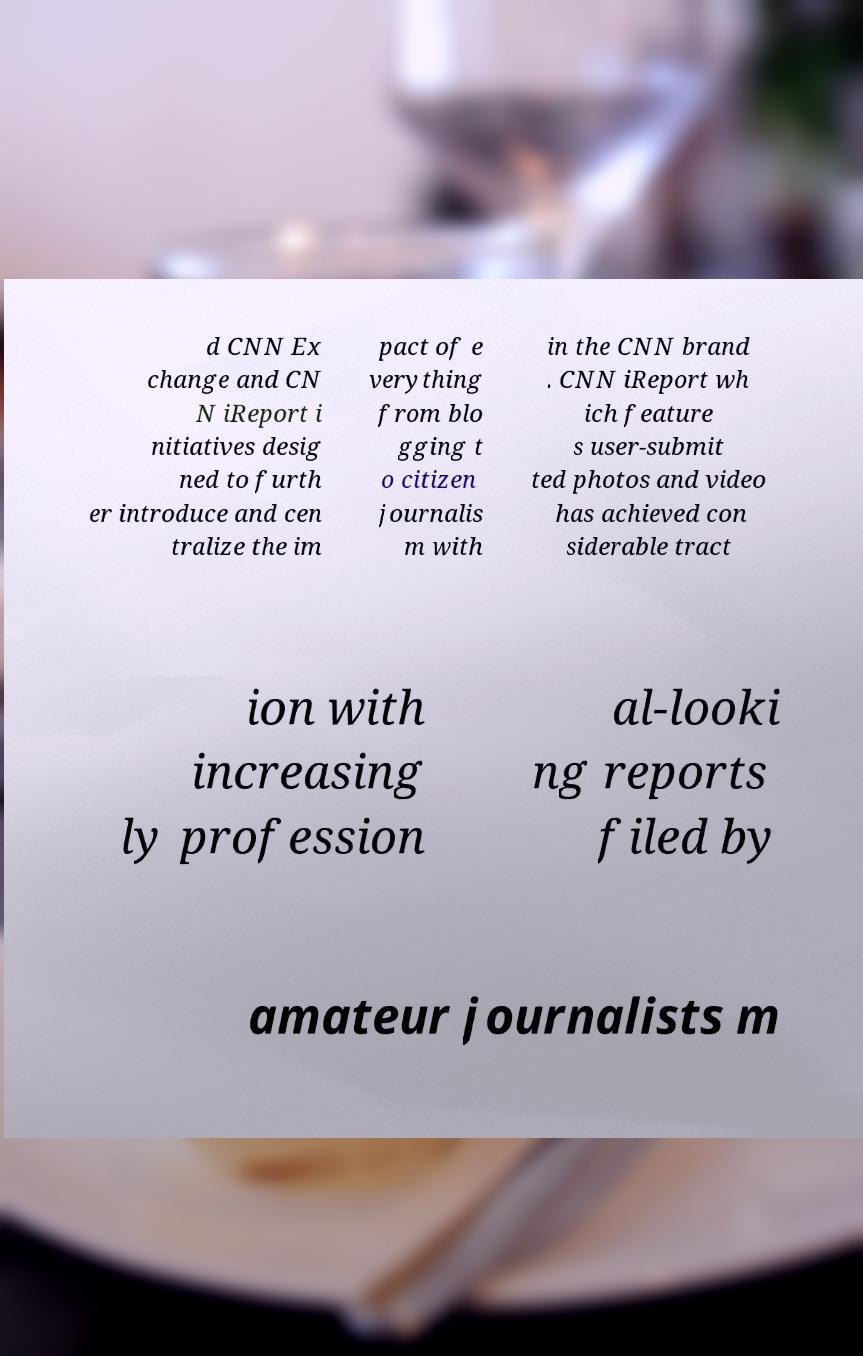Please read and relay the text visible in this image. What does it say? d CNN Ex change and CN N iReport i nitiatives desig ned to furth er introduce and cen tralize the im pact of e verything from blo gging t o citizen journalis m with in the CNN brand . CNN iReport wh ich feature s user-submit ted photos and video has achieved con siderable tract ion with increasing ly profession al-looki ng reports filed by amateur journalists m 